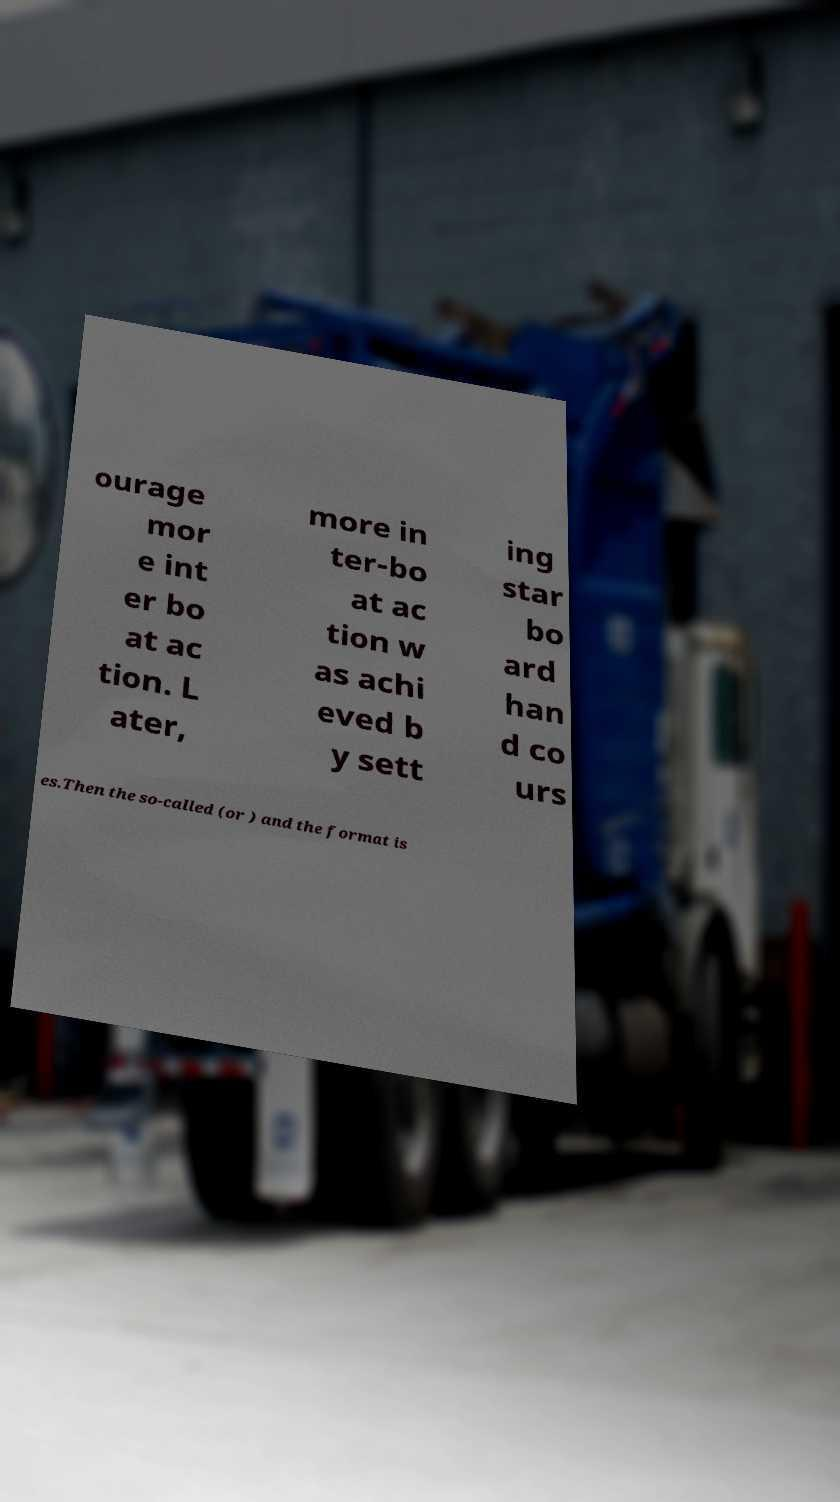What messages or text are displayed in this image? I need them in a readable, typed format. ourage mor e int er bo at ac tion. L ater, more in ter-bo at ac tion w as achi eved b y sett ing star bo ard han d co urs es.Then the so-called (or ) and the format is 